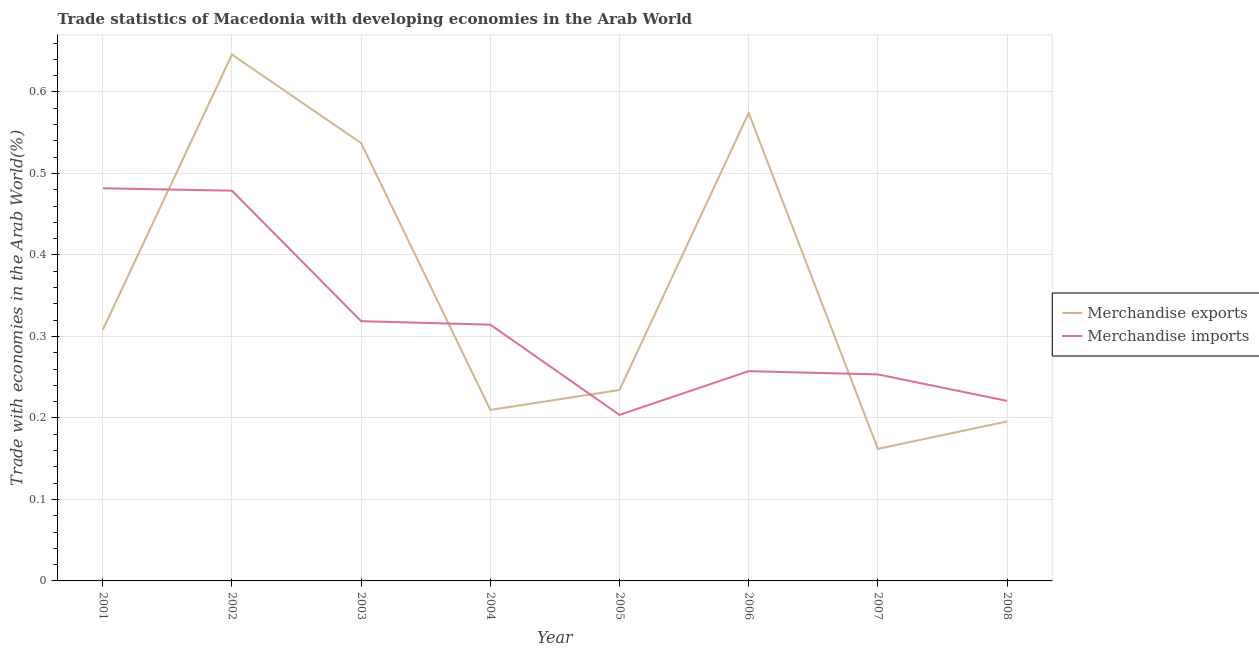Does the line corresponding to merchandise imports intersect with the line corresponding to merchandise exports?
Your answer should be compact. Yes. Is the number of lines equal to the number of legend labels?
Give a very brief answer. Yes. What is the merchandise imports in 2007?
Keep it short and to the point. 0.25. Across all years, what is the maximum merchandise exports?
Your answer should be compact. 0.65. Across all years, what is the minimum merchandise exports?
Your answer should be very brief. 0.16. In which year was the merchandise exports minimum?
Offer a terse response. 2007. What is the total merchandise exports in the graph?
Offer a very short reply. 2.87. What is the difference between the merchandise imports in 2006 and that in 2007?
Give a very brief answer. 0. What is the difference between the merchandise exports in 2003 and the merchandise imports in 2006?
Offer a terse response. 0.28. What is the average merchandise exports per year?
Give a very brief answer. 0.36. In the year 2001, what is the difference between the merchandise exports and merchandise imports?
Your answer should be very brief. -0.17. What is the ratio of the merchandise exports in 2003 to that in 2005?
Make the answer very short. 2.29. What is the difference between the highest and the second highest merchandise exports?
Your response must be concise. 0.07. What is the difference between the highest and the lowest merchandise exports?
Keep it short and to the point. 0.48. In how many years, is the merchandise imports greater than the average merchandise imports taken over all years?
Offer a terse response. 3. Is the sum of the merchandise exports in 2007 and 2008 greater than the maximum merchandise imports across all years?
Offer a terse response. No. Is the merchandise exports strictly greater than the merchandise imports over the years?
Give a very brief answer. No. How many lines are there?
Give a very brief answer. 2. Are the values on the major ticks of Y-axis written in scientific E-notation?
Provide a succinct answer. No. Does the graph contain grids?
Your response must be concise. Yes. How many legend labels are there?
Your answer should be very brief. 2. How are the legend labels stacked?
Provide a succinct answer. Vertical. What is the title of the graph?
Make the answer very short. Trade statistics of Macedonia with developing economies in the Arab World. Does "Primary income" appear as one of the legend labels in the graph?
Provide a succinct answer. No. What is the label or title of the X-axis?
Provide a short and direct response. Year. What is the label or title of the Y-axis?
Provide a short and direct response. Trade with economies in the Arab World(%). What is the Trade with economies in the Arab World(%) of Merchandise exports in 2001?
Give a very brief answer. 0.31. What is the Trade with economies in the Arab World(%) of Merchandise imports in 2001?
Provide a succinct answer. 0.48. What is the Trade with economies in the Arab World(%) of Merchandise exports in 2002?
Give a very brief answer. 0.65. What is the Trade with economies in the Arab World(%) in Merchandise imports in 2002?
Offer a terse response. 0.48. What is the Trade with economies in the Arab World(%) in Merchandise exports in 2003?
Provide a short and direct response. 0.54. What is the Trade with economies in the Arab World(%) of Merchandise imports in 2003?
Offer a terse response. 0.32. What is the Trade with economies in the Arab World(%) in Merchandise exports in 2004?
Provide a succinct answer. 0.21. What is the Trade with economies in the Arab World(%) in Merchandise imports in 2004?
Ensure brevity in your answer.  0.31. What is the Trade with economies in the Arab World(%) in Merchandise exports in 2005?
Your answer should be compact. 0.23. What is the Trade with economies in the Arab World(%) of Merchandise imports in 2005?
Your answer should be compact. 0.2. What is the Trade with economies in the Arab World(%) in Merchandise exports in 2006?
Offer a terse response. 0.57. What is the Trade with economies in the Arab World(%) in Merchandise imports in 2006?
Offer a terse response. 0.26. What is the Trade with economies in the Arab World(%) in Merchandise exports in 2007?
Your answer should be very brief. 0.16. What is the Trade with economies in the Arab World(%) in Merchandise imports in 2007?
Your answer should be very brief. 0.25. What is the Trade with economies in the Arab World(%) of Merchandise exports in 2008?
Your answer should be compact. 0.2. What is the Trade with economies in the Arab World(%) in Merchandise imports in 2008?
Your response must be concise. 0.22. Across all years, what is the maximum Trade with economies in the Arab World(%) in Merchandise exports?
Provide a succinct answer. 0.65. Across all years, what is the maximum Trade with economies in the Arab World(%) of Merchandise imports?
Provide a succinct answer. 0.48. Across all years, what is the minimum Trade with economies in the Arab World(%) of Merchandise exports?
Offer a very short reply. 0.16. Across all years, what is the minimum Trade with economies in the Arab World(%) in Merchandise imports?
Keep it short and to the point. 0.2. What is the total Trade with economies in the Arab World(%) of Merchandise exports in the graph?
Provide a short and direct response. 2.87. What is the total Trade with economies in the Arab World(%) of Merchandise imports in the graph?
Offer a very short reply. 2.53. What is the difference between the Trade with economies in the Arab World(%) of Merchandise exports in 2001 and that in 2002?
Ensure brevity in your answer.  -0.34. What is the difference between the Trade with economies in the Arab World(%) in Merchandise imports in 2001 and that in 2002?
Your answer should be very brief. 0. What is the difference between the Trade with economies in the Arab World(%) of Merchandise exports in 2001 and that in 2003?
Your answer should be very brief. -0.23. What is the difference between the Trade with economies in the Arab World(%) in Merchandise imports in 2001 and that in 2003?
Your answer should be very brief. 0.16. What is the difference between the Trade with economies in the Arab World(%) of Merchandise exports in 2001 and that in 2004?
Your response must be concise. 0.1. What is the difference between the Trade with economies in the Arab World(%) of Merchandise imports in 2001 and that in 2004?
Your response must be concise. 0.17. What is the difference between the Trade with economies in the Arab World(%) in Merchandise exports in 2001 and that in 2005?
Give a very brief answer. 0.07. What is the difference between the Trade with economies in the Arab World(%) of Merchandise imports in 2001 and that in 2005?
Give a very brief answer. 0.28. What is the difference between the Trade with economies in the Arab World(%) of Merchandise exports in 2001 and that in 2006?
Ensure brevity in your answer.  -0.27. What is the difference between the Trade with economies in the Arab World(%) in Merchandise imports in 2001 and that in 2006?
Provide a succinct answer. 0.22. What is the difference between the Trade with economies in the Arab World(%) of Merchandise exports in 2001 and that in 2007?
Provide a succinct answer. 0.15. What is the difference between the Trade with economies in the Arab World(%) of Merchandise imports in 2001 and that in 2007?
Your answer should be compact. 0.23. What is the difference between the Trade with economies in the Arab World(%) in Merchandise exports in 2001 and that in 2008?
Provide a succinct answer. 0.11. What is the difference between the Trade with economies in the Arab World(%) of Merchandise imports in 2001 and that in 2008?
Provide a succinct answer. 0.26. What is the difference between the Trade with economies in the Arab World(%) in Merchandise exports in 2002 and that in 2003?
Ensure brevity in your answer.  0.11. What is the difference between the Trade with economies in the Arab World(%) of Merchandise imports in 2002 and that in 2003?
Your answer should be very brief. 0.16. What is the difference between the Trade with economies in the Arab World(%) of Merchandise exports in 2002 and that in 2004?
Give a very brief answer. 0.44. What is the difference between the Trade with economies in the Arab World(%) of Merchandise imports in 2002 and that in 2004?
Keep it short and to the point. 0.16. What is the difference between the Trade with economies in the Arab World(%) of Merchandise exports in 2002 and that in 2005?
Give a very brief answer. 0.41. What is the difference between the Trade with economies in the Arab World(%) of Merchandise imports in 2002 and that in 2005?
Your answer should be compact. 0.28. What is the difference between the Trade with economies in the Arab World(%) in Merchandise exports in 2002 and that in 2006?
Offer a very short reply. 0.07. What is the difference between the Trade with economies in the Arab World(%) in Merchandise imports in 2002 and that in 2006?
Keep it short and to the point. 0.22. What is the difference between the Trade with economies in the Arab World(%) of Merchandise exports in 2002 and that in 2007?
Make the answer very short. 0.48. What is the difference between the Trade with economies in the Arab World(%) in Merchandise imports in 2002 and that in 2007?
Give a very brief answer. 0.23. What is the difference between the Trade with economies in the Arab World(%) of Merchandise exports in 2002 and that in 2008?
Your answer should be compact. 0.45. What is the difference between the Trade with economies in the Arab World(%) of Merchandise imports in 2002 and that in 2008?
Keep it short and to the point. 0.26. What is the difference between the Trade with economies in the Arab World(%) in Merchandise exports in 2003 and that in 2004?
Keep it short and to the point. 0.33. What is the difference between the Trade with economies in the Arab World(%) in Merchandise imports in 2003 and that in 2004?
Give a very brief answer. 0. What is the difference between the Trade with economies in the Arab World(%) in Merchandise exports in 2003 and that in 2005?
Offer a very short reply. 0.3. What is the difference between the Trade with economies in the Arab World(%) in Merchandise imports in 2003 and that in 2005?
Offer a very short reply. 0.12. What is the difference between the Trade with economies in the Arab World(%) of Merchandise exports in 2003 and that in 2006?
Your response must be concise. -0.04. What is the difference between the Trade with economies in the Arab World(%) in Merchandise imports in 2003 and that in 2006?
Offer a terse response. 0.06. What is the difference between the Trade with economies in the Arab World(%) of Merchandise exports in 2003 and that in 2007?
Give a very brief answer. 0.38. What is the difference between the Trade with economies in the Arab World(%) of Merchandise imports in 2003 and that in 2007?
Make the answer very short. 0.07. What is the difference between the Trade with economies in the Arab World(%) of Merchandise exports in 2003 and that in 2008?
Provide a short and direct response. 0.34. What is the difference between the Trade with economies in the Arab World(%) in Merchandise imports in 2003 and that in 2008?
Give a very brief answer. 0.1. What is the difference between the Trade with economies in the Arab World(%) in Merchandise exports in 2004 and that in 2005?
Offer a terse response. -0.02. What is the difference between the Trade with economies in the Arab World(%) in Merchandise imports in 2004 and that in 2005?
Offer a terse response. 0.11. What is the difference between the Trade with economies in the Arab World(%) of Merchandise exports in 2004 and that in 2006?
Your answer should be very brief. -0.36. What is the difference between the Trade with economies in the Arab World(%) of Merchandise imports in 2004 and that in 2006?
Offer a very short reply. 0.06. What is the difference between the Trade with economies in the Arab World(%) in Merchandise exports in 2004 and that in 2007?
Ensure brevity in your answer.  0.05. What is the difference between the Trade with economies in the Arab World(%) of Merchandise imports in 2004 and that in 2007?
Your response must be concise. 0.06. What is the difference between the Trade with economies in the Arab World(%) of Merchandise exports in 2004 and that in 2008?
Provide a succinct answer. 0.01. What is the difference between the Trade with economies in the Arab World(%) of Merchandise imports in 2004 and that in 2008?
Your answer should be very brief. 0.09. What is the difference between the Trade with economies in the Arab World(%) in Merchandise exports in 2005 and that in 2006?
Ensure brevity in your answer.  -0.34. What is the difference between the Trade with economies in the Arab World(%) in Merchandise imports in 2005 and that in 2006?
Your answer should be very brief. -0.05. What is the difference between the Trade with economies in the Arab World(%) in Merchandise exports in 2005 and that in 2007?
Provide a short and direct response. 0.07. What is the difference between the Trade with economies in the Arab World(%) in Merchandise imports in 2005 and that in 2007?
Your response must be concise. -0.05. What is the difference between the Trade with economies in the Arab World(%) in Merchandise exports in 2005 and that in 2008?
Provide a short and direct response. 0.04. What is the difference between the Trade with economies in the Arab World(%) in Merchandise imports in 2005 and that in 2008?
Keep it short and to the point. -0.02. What is the difference between the Trade with economies in the Arab World(%) in Merchandise exports in 2006 and that in 2007?
Ensure brevity in your answer.  0.41. What is the difference between the Trade with economies in the Arab World(%) of Merchandise imports in 2006 and that in 2007?
Keep it short and to the point. 0. What is the difference between the Trade with economies in the Arab World(%) of Merchandise exports in 2006 and that in 2008?
Ensure brevity in your answer.  0.38. What is the difference between the Trade with economies in the Arab World(%) in Merchandise imports in 2006 and that in 2008?
Provide a succinct answer. 0.04. What is the difference between the Trade with economies in the Arab World(%) in Merchandise exports in 2007 and that in 2008?
Provide a succinct answer. -0.03. What is the difference between the Trade with economies in the Arab World(%) of Merchandise imports in 2007 and that in 2008?
Your response must be concise. 0.03. What is the difference between the Trade with economies in the Arab World(%) of Merchandise exports in 2001 and the Trade with economies in the Arab World(%) of Merchandise imports in 2002?
Provide a succinct answer. -0.17. What is the difference between the Trade with economies in the Arab World(%) of Merchandise exports in 2001 and the Trade with economies in the Arab World(%) of Merchandise imports in 2003?
Make the answer very short. -0.01. What is the difference between the Trade with economies in the Arab World(%) of Merchandise exports in 2001 and the Trade with economies in the Arab World(%) of Merchandise imports in 2004?
Make the answer very short. -0.01. What is the difference between the Trade with economies in the Arab World(%) of Merchandise exports in 2001 and the Trade with economies in the Arab World(%) of Merchandise imports in 2005?
Make the answer very short. 0.1. What is the difference between the Trade with economies in the Arab World(%) in Merchandise exports in 2001 and the Trade with economies in the Arab World(%) in Merchandise imports in 2006?
Provide a short and direct response. 0.05. What is the difference between the Trade with economies in the Arab World(%) in Merchandise exports in 2001 and the Trade with economies in the Arab World(%) in Merchandise imports in 2007?
Provide a short and direct response. 0.05. What is the difference between the Trade with economies in the Arab World(%) in Merchandise exports in 2001 and the Trade with economies in the Arab World(%) in Merchandise imports in 2008?
Offer a terse response. 0.09. What is the difference between the Trade with economies in the Arab World(%) of Merchandise exports in 2002 and the Trade with economies in the Arab World(%) of Merchandise imports in 2003?
Ensure brevity in your answer.  0.33. What is the difference between the Trade with economies in the Arab World(%) of Merchandise exports in 2002 and the Trade with economies in the Arab World(%) of Merchandise imports in 2004?
Provide a short and direct response. 0.33. What is the difference between the Trade with economies in the Arab World(%) of Merchandise exports in 2002 and the Trade with economies in the Arab World(%) of Merchandise imports in 2005?
Your answer should be very brief. 0.44. What is the difference between the Trade with economies in the Arab World(%) in Merchandise exports in 2002 and the Trade with economies in the Arab World(%) in Merchandise imports in 2006?
Offer a very short reply. 0.39. What is the difference between the Trade with economies in the Arab World(%) of Merchandise exports in 2002 and the Trade with economies in the Arab World(%) of Merchandise imports in 2007?
Make the answer very short. 0.39. What is the difference between the Trade with economies in the Arab World(%) in Merchandise exports in 2002 and the Trade with economies in the Arab World(%) in Merchandise imports in 2008?
Your answer should be compact. 0.42. What is the difference between the Trade with economies in the Arab World(%) of Merchandise exports in 2003 and the Trade with economies in the Arab World(%) of Merchandise imports in 2004?
Give a very brief answer. 0.22. What is the difference between the Trade with economies in the Arab World(%) of Merchandise exports in 2003 and the Trade with economies in the Arab World(%) of Merchandise imports in 2005?
Your response must be concise. 0.33. What is the difference between the Trade with economies in the Arab World(%) of Merchandise exports in 2003 and the Trade with economies in the Arab World(%) of Merchandise imports in 2006?
Keep it short and to the point. 0.28. What is the difference between the Trade with economies in the Arab World(%) of Merchandise exports in 2003 and the Trade with economies in the Arab World(%) of Merchandise imports in 2007?
Give a very brief answer. 0.28. What is the difference between the Trade with economies in the Arab World(%) in Merchandise exports in 2003 and the Trade with economies in the Arab World(%) in Merchandise imports in 2008?
Offer a very short reply. 0.32. What is the difference between the Trade with economies in the Arab World(%) in Merchandise exports in 2004 and the Trade with economies in the Arab World(%) in Merchandise imports in 2005?
Provide a succinct answer. 0.01. What is the difference between the Trade with economies in the Arab World(%) in Merchandise exports in 2004 and the Trade with economies in the Arab World(%) in Merchandise imports in 2006?
Keep it short and to the point. -0.05. What is the difference between the Trade with economies in the Arab World(%) in Merchandise exports in 2004 and the Trade with economies in the Arab World(%) in Merchandise imports in 2007?
Give a very brief answer. -0.04. What is the difference between the Trade with economies in the Arab World(%) in Merchandise exports in 2004 and the Trade with economies in the Arab World(%) in Merchandise imports in 2008?
Your answer should be very brief. -0.01. What is the difference between the Trade with economies in the Arab World(%) of Merchandise exports in 2005 and the Trade with economies in the Arab World(%) of Merchandise imports in 2006?
Give a very brief answer. -0.02. What is the difference between the Trade with economies in the Arab World(%) in Merchandise exports in 2005 and the Trade with economies in the Arab World(%) in Merchandise imports in 2007?
Offer a terse response. -0.02. What is the difference between the Trade with economies in the Arab World(%) in Merchandise exports in 2005 and the Trade with economies in the Arab World(%) in Merchandise imports in 2008?
Your response must be concise. 0.01. What is the difference between the Trade with economies in the Arab World(%) of Merchandise exports in 2006 and the Trade with economies in the Arab World(%) of Merchandise imports in 2007?
Make the answer very short. 0.32. What is the difference between the Trade with economies in the Arab World(%) in Merchandise exports in 2006 and the Trade with economies in the Arab World(%) in Merchandise imports in 2008?
Your answer should be very brief. 0.35. What is the difference between the Trade with economies in the Arab World(%) in Merchandise exports in 2007 and the Trade with economies in the Arab World(%) in Merchandise imports in 2008?
Your response must be concise. -0.06. What is the average Trade with economies in the Arab World(%) in Merchandise exports per year?
Offer a terse response. 0.36. What is the average Trade with economies in the Arab World(%) in Merchandise imports per year?
Give a very brief answer. 0.32. In the year 2001, what is the difference between the Trade with economies in the Arab World(%) of Merchandise exports and Trade with economies in the Arab World(%) of Merchandise imports?
Provide a short and direct response. -0.17. In the year 2002, what is the difference between the Trade with economies in the Arab World(%) of Merchandise exports and Trade with economies in the Arab World(%) of Merchandise imports?
Your answer should be very brief. 0.17. In the year 2003, what is the difference between the Trade with economies in the Arab World(%) in Merchandise exports and Trade with economies in the Arab World(%) in Merchandise imports?
Your response must be concise. 0.22. In the year 2004, what is the difference between the Trade with economies in the Arab World(%) of Merchandise exports and Trade with economies in the Arab World(%) of Merchandise imports?
Offer a very short reply. -0.1. In the year 2005, what is the difference between the Trade with economies in the Arab World(%) of Merchandise exports and Trade with economies in the Arab World(%) of Merchandise imports?
Make the answer very short. 0.03. In the year 2006, what is the difference between the Trade with economies in the Arab World(%) in Merchandise exports and Trade with economies in the Arab World(%) in Merchandise imports?
Your answer should be compact. 0.32. In the year 2007, what is the difference between the Trade with economies in the Arab World(%) of Merchandise exports and Trade with economies in the Arab World(%) of Merchandise imports?
Give a very brief answer. -0.09. In the year 2008, what is the difference between the Trade with economies in the Arab World(%) in Merchandise exports and Trade with economies in the Arab World(%) in Merchandise imports?
Your answer should be compact. -0.03. What is the ratio of the Trade with economies in the Arab World(%) of Merchandise exports in 2001 to that in 2002?
Offer a terse response. 0.48. What is the ratio of the Trade with economies in the Arab World(%) of Merchandise imports in 2001 to that in 2002?
Offer a very short reply. 1.01. What is the ratio of the Trade with economies in the Arab World(%) in Merchandise exports in 2001 to that in 2003?
Make the answer very short. 0.57. What is the ratio of the Trade with economies in the Arab World(%) in Merchandise imports in 2001 to that in 2003?
Offer a very short reply. 1.51. What is the ratio of the Trade with economies in the Arab World(%) of Merchandise exports in 2001 to that in 2004?
Provide a succinct answer. 1.47. What is the ratio of the Trade with economies in the Arab World(%) in Merchandise imports in 2001 to that in 2004?
Ensure brevity in your answer.  1.53. What is the ratio of the Trade with economies in the Arab World(%) in Merchandise exports in 2001 to that in 2005?
Keep it short and to the point. 1.31. What is the ratio of the Trade with economies in the Arab World(%) in Merchandise imports in 2001 to that in 2005?
Give a very brief answer. 2.36. What is the ratio of the Trade with economies in the Arab World(%) in Merchandise exports in 2001 to that in 2006?
Offer a terse response. 0.54. What is the ratio of the Trade with economies in the Arab World(%) in Merchandise imports in 2001 to that in 2006?
Your response must be concise. 1.87. What is the ratio of the Trade with economies in the Arab World(%) in Merchandise exports in 2001 to that in 2007?
Provide a short and direct response. 1.9. What is the ratio of the Trade with economies in the Arab World(%) in Merchandise imports in 2001 to that in 2007?
Provide a succinct answer. 1.9. What is the ratio of the Trade with economies in the Arab World(%) of Merchandise exports in 2001 to that in 2008?
Provide a succinct answer. 1.57. What is the ratio of the Trade with economies in the Arab World(%) of Merchandise imports in 2001 to that in 2008?
Offer a very short reply. 2.18. What is the ratio of the Trade with economies in the Arab World(%) in Merchandise exports in 2002 to that in 2003?
Keep it short and to the point. 1.2. What is the ratio of the Trade with economies in the Arab World(%) in Merchandise imports in 2002 to that in 2003?
Keep it short and to the point. 1.5. What is the ratio of the Trade with economies in the Arab World(%) of Merchandise exports in 2002 to that in 2004?
Give a very brief answer. 3.08. What is the ratio of the Trade with economies in the Arab World(%) in Merchandise imports in 2002 to that in 2004?
Ensure brevity in your answer.  1.52. What is the ratio of the Trade with economies in the Arab World(%) of Merchandise exports in 2002 to that in 2005?
Provide a short and direct response. 2.76. What is the ratio of the Trade with economies in the Arab World(%) of Merchandise imports in 2002 to that in 2005?
Your response must be concise. 2.35. What is the ratio of the Trade with economies in the Arab World(%) of Merchandise exports in 2002 to that in 2006?
Your answer should be very brief. 1.12. What is the ratio of the Trade with economies in the Arab World(%) of Merchandise imports in 2002 to that in 2006?
Keep it short and to the point. 1.86. What is the ratio of the Trade with economies in the Arab World(%) of Merchandise exports in 2002 to that in 2007?
Your response must be concise. 3.98. What is the ratio of the Trade with economies in the Arab World(%) in Merchandise imports in 2002 to that in 2007?
Ensure brevity in your answer.  1.89. What is the ratio of the Trade with economies in the Arab World(%) of Merchandise exports in 2002 to that in 2008?
Make the answer very short. 3.3. What is the ratio of the Trade with economies in the Arab World(%) in Merchandise imports in 2002 to that in 2008?
Provide a short and direct response. 2.17. What is the ratio of the Trade with economies in the Arab World(%) of Merchandise exports in 2003 to that in 2004?
Provide a short and direct response. 2.56. What is the ratio of the Trade with economies in the Arab World(%) of Merchandise imports in 2003 to that in 2004?
Keep it short and to the point. 1.01. What is the ratio of the Trade with economies in the Arab World(%) of Merchandise exports in 2003 to that in 2005?
Your answer should be compact. 2.29. What is the ratio of the Trade with economies in the Arab World(%) in Merchandise imports in 2003 to that in 2005?
Keep it short and to the point. 1.56. What is the ratio of the Trade with economies in the Arab World(%) of Merchandise exports in 2003 to that in 2006?
Offer a terse response. 0.94. What is the ratio of the Trade with economies in the Arab World(%) of Merchandise imports in 2003 to that in 2006?
Offer a terse response. 1.24. What is the ratio of the Trade with economies in the Arab World(%) of Merchandise exports in 2003 to that in 2007?
Keep it short and to the point. 3.32. What is the ratio of the Trade with economies in the Arab World(%) of Merchandise imports in 2003 to that in 2007?
Provide a succinct answer. 1.26. What is the ratio of the Trade with economies in the Arab World(%) of Merchandise exports in 2003 to that in 2008?
Give a very brief answer. 2.75. What is the ratio of the Trade with economies in the Arab World(%) in Merchandise imports in 2003 to that in 2008?
Your answer should be compact. 1.44. What is the ratio of the Trade with economies in the Arab World(%) in Merchandise exports in 2004 to that in 2005?
Your answer should be very brief. 0.9. What is the ratio of the Trade with economies in the Arab World(%) of Merchandise imports in 2004 to that in 2005?
Offer a terse response. 1.54. What is the ratio of the Trade with economies in the Arab World(%) in Merchandise exports in 2004 to that in 2006?
Offer a terse response. 0.37. What is the ratio of the Trade with economies in the Arab World(%) in Merchandise imports in 2004 to that in 2006?
Keep it short and to the point. 1.22. What is the ratio of the Trade with economies in the Arab World(%) of Merchandise exports in 2004 to that in 2007?
Make the answer very short. 1.29. What is the ratio of the Trade with economies in the Arab World(%) in Merchandise imports in 2004 to that in 2007?
Give a very brief answer. 1.24. What is the ratio of the Trade with economies in the Arab World(%) in Merchandise exports in 2004 to that in 2008?
Your answer should be very brief. 1.07. What is the ratio of the Trade with economies in the Arab World(%) of Merchandise imports in 2004 to that in 2008?
Provide a short and direct response. 1.42. What is the ratio of the Trade with economies in the Arab World(%) in Merchandise exports in 2005 to that in 2006?
Ensure brevity in your answer.  0.41. What is the ratio of the Trade with economies in the Arab World(%) of Merchandise imports in 2005 to that in 2006?
Offer a very short reply. 0.79. What is the ratio of the Trade with economies in the Arab World(%) in Merchandise exports in 2005 to that in 2007?
Provide a succinct answer. 1.45. What is the ratio of the Trade with economies in the Arab World(%) in Merchandise imports in 2005 to that in 2007?
Provide a succinct answer. 0.8. What is the ratio of the Trade with economies in the Arab World(%) in Merchandise exports in 2005 to that in 2008?
Your answer should be very brief. 1.2. What is the ratio of the Trade with economies in the Arab World(%) of Merchandise imports in 2005 to that in 2008?
Your answer should be very brief. 0.92. What is the ratio of the Trade with economies in the Arab World(%) of Merchandise exports in 2006 to that in 2007?
Give a very brief answer. 3.54. What is the ratio of the Trade with economies in the Arab World(%) of Merchandise imports in 2006 to that in 2007?
Ensure brevity in your answer.  1.02. What is the ratio of the Trade with economies in the Arab World(%) in Merchandise exports in 2006 to that in 2008?
Ensure brevity in your answer.  2.93. What is the ratio of the Trade with economies in the Arab World(%) in Merchandise imports in 2006 to that in 2008?
Your answer should be very brief. 1.16. What is the ratio of the Trade with economies in the Arab World(%) of Merchandise exports in 2007 to that in 2008?
Give a very brief answer. 0.83. What is the ratio of the Trade with economies in the Arab World(%) of Merchandise imports in 2007 to that in 2008?
Offer a very short reply. 1.15. What is the difference between the highest and the second highest Trade with economies in the Arab World(%) of Merchandise exports?
Your answer should be very brief. 0.07. What is the difference between the highest and the second highest Trade with economies in the Arab World(%) of Merchandise imports?
Ensure brevity in your answer.  0. What is the difference between the highest and the lowest Trade with economies in the Arab World(%) of Merchandise exports?
Give a very brief answer. 0.48. What is the difference between the highest and the lowest Trade with economies in the Arab World(%) in Merchandise imports?
Ensure brevity in your answer.  0.28. 